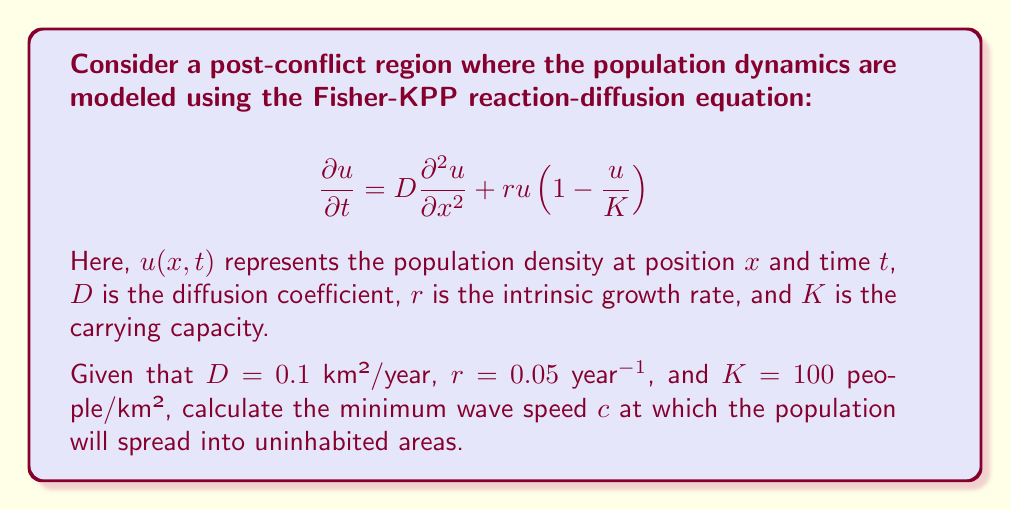Help me with this question. To solve this problem, we need to understand the concept of traveling wave solutions in reaction-diffusion equations. For the Fisher-KPP equation, there exists a minimum wave speed at which the population will spread into uninhabited areas.

The minimum wave speed for the Fisher-KPP equation is given by the formula:

$$c_{min} = 2\sqrt{rD}$$

Where:
- $c_{min}$ is the minimum wave speed
- $r$ is the intrinsic growth rate
- $D$ is the diffusion coefficient

Let's substitute the given values:
- $D = 0.1$ km²/year
- $r = 0.05$ year⁻¹

Now, we can calculate:

$$\begin{align*}
c_{min} &= 2\sqrt{rD} \\
&= 2\sqrt{(0.05\text{ year}^{-1})(0.1\text{ km}^2/\text{year})} \\
&= 2\sqrt{0.005\text{ km}^2/\text{year}^2} \\
&= 2(0.0707\text{ km/year}) \\
&= 0.1414\text{ km/year}
\end{align*}$$

This result indicates that the population will spread into uninhabited areas at a minimum speed of approximately 0.1414 km per year.

Note: The carrying capacity $K$ does not affect the minimum wave speed in this model, but it does influence the shape of the traveling wave and the equilibrium population density.
Answer: The minimum wave speed at which the population will spread into uninhabited areas is approximately 0.1414 km/year. 